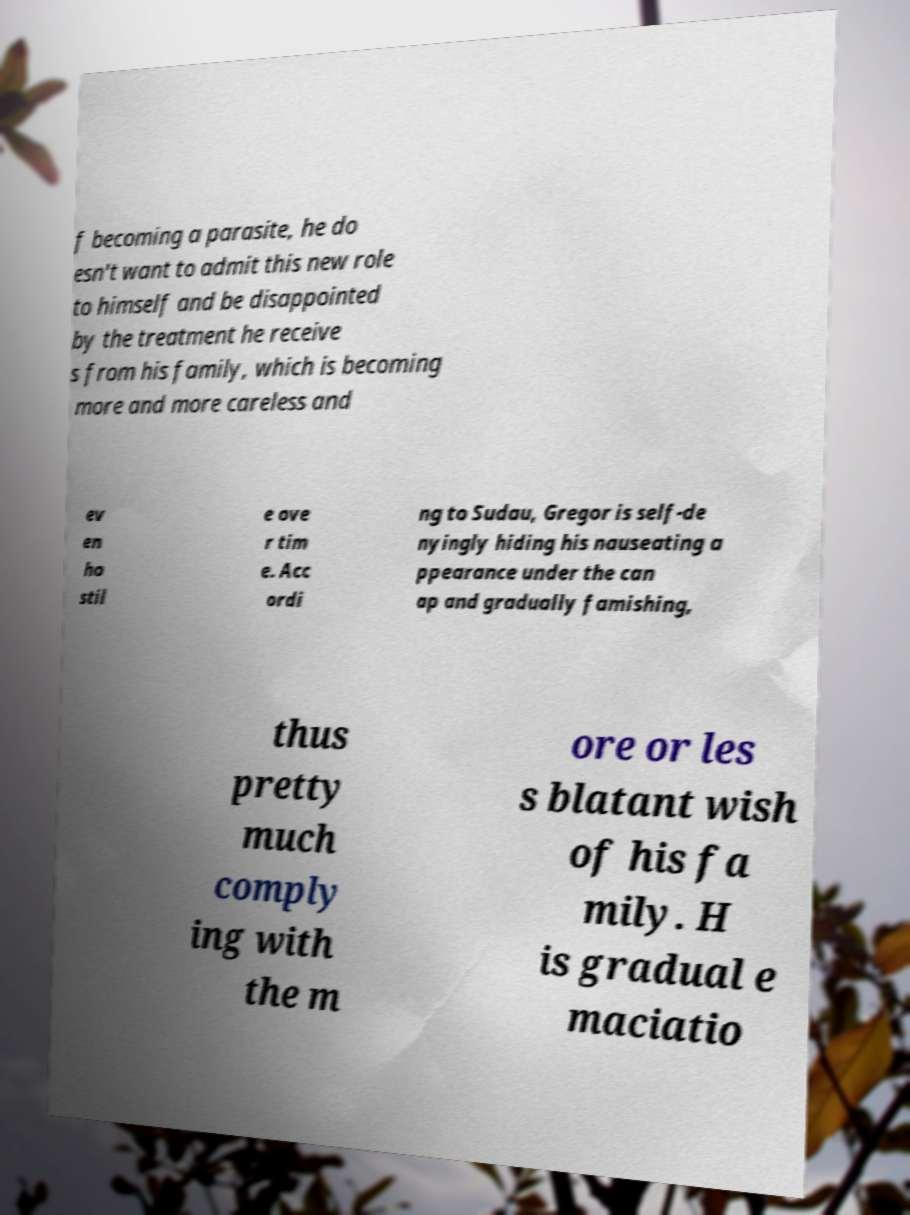I need the written content from this picture converted into text. Can you do that? f becoming a parasite, he do esn't want to admit this new role to himself and be disappointed by the treatment he receive s from his family, which is becoming more and more careless and ev en ho stil e ove r tim e. Acc ordi ng to Sudau, Gregor is self-de nyingly hiding his nauseating a ppearance under the can ap and gradually famishing, thus pretty much comply ing with the m ore or les s blatant wish of his fa mily. H is gradual e maciatio 